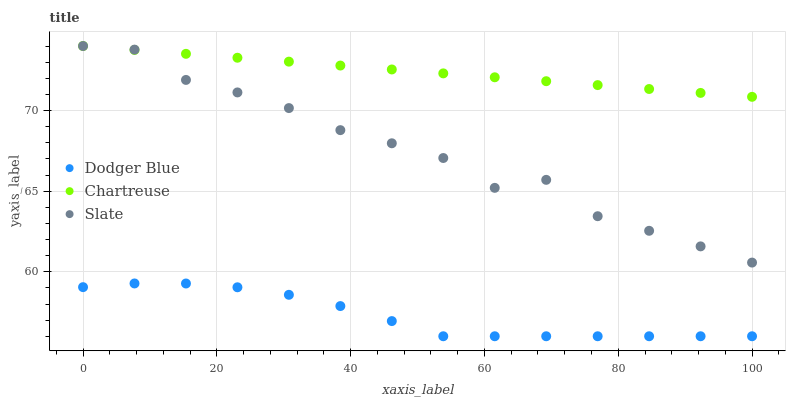Does Dodger Blue have the minimum area under the curve?
Answer yes or no. Yes. Does Chartreuse have the maximum area under the curve?
Answer yes or no. Yes. Does Slate have the minimum area under the curve?
Answer yes or no. No. Does Slate have the maximum area under the curve?
Answer yes or no. No. Is Chartreuse the smoothest?
Answer yes or no. Yes. Is Slate the roughest?
Answer yes or no. Yes. Is Dodger Blue the smoothest?
Answer yes or no. No. Is Dodger Blue the roughest?
Answer yes or no. No. Does Dodger Blue have the lowest value?
Answer yes or no. Yes. Does Slate have the lowest value?
Answer yes or no. No. Does Slate have the highest value?
Answer yes or no. Yes. Does Dodger Blue have the highest value?
Answer yes or no. No. Is Dodger Blue less than Slate?
Answer yes or no. Yes. Is Chartreuse greater than Dodger Blue?
Answer yes or no. Yes. Does Chartreuse intersect Slate?
Answer yes or no. Yes. Is Chartreuse less than Slate?
Answer yes or no. No. Is Chartreuse greater than Slate?
Answer yes or no. No. Does Dodger Blue intersect Slate?
Answer yes or no. No. 